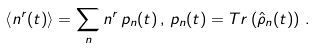Convert formula to latex. <formula><loc_0><loc_0><loc_500><loc_500>\left \langle n ^ { r } ( t ) \right \rangle = \sum _ { n } n ^ { r } \, p _ { n } ( t ) \, , \, p _ { n } ( t ) = T r \left ( \hat { \rho } _ { n } ( t ) \right ) \, .</formula> 